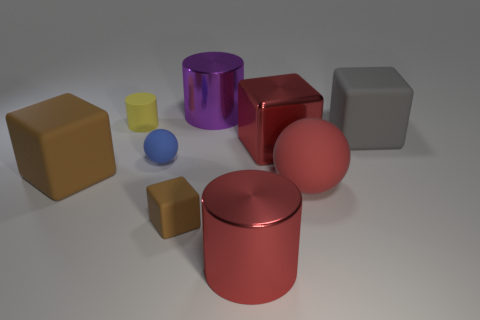Subtract all blocks. How many objects are left? 5 Subtract all red matte spheres. Subtract all matte cubes. How many objects are left? 5 Add 7 brown blocks. How many brown blocks are left? 9 Add 8 metallic cylinders. How many metallic cylinders exist? 10 Subtract 0 cyan spheres. How many objects are left? 9 